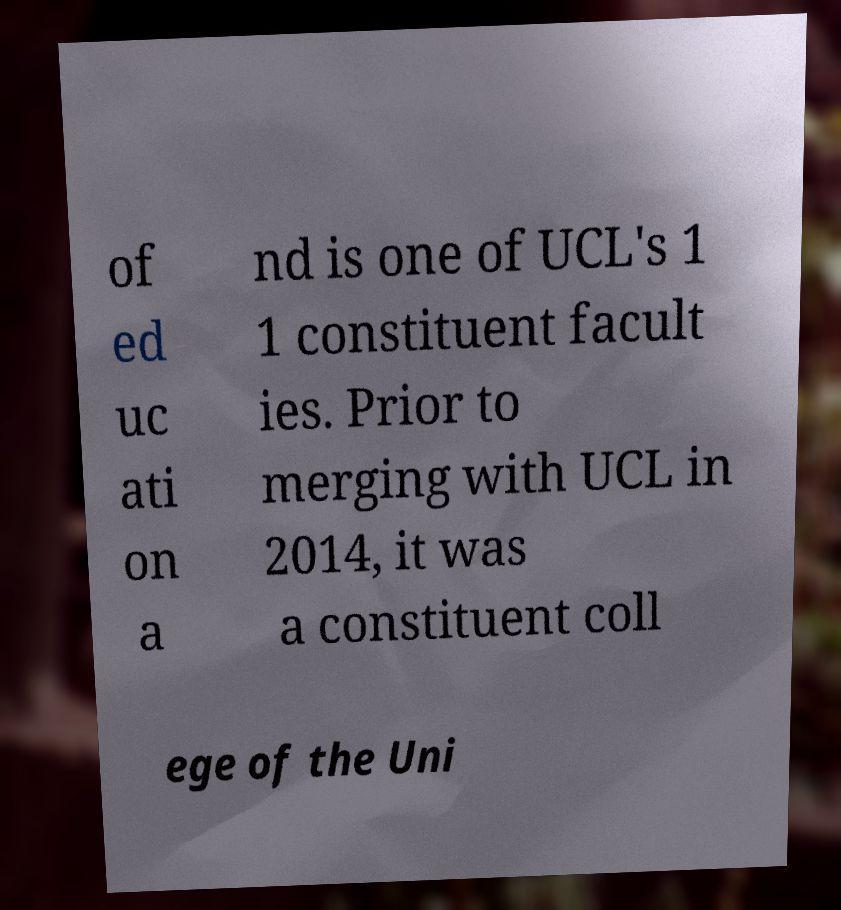What messages or text are displayed in this image? I need them in a readable, typed format. of ed uc ati on a nd is one of UCL's 1 1 constituent facult ies. Prior to merging with UCL in 2014, it was a constituent coll ege of the Uni 